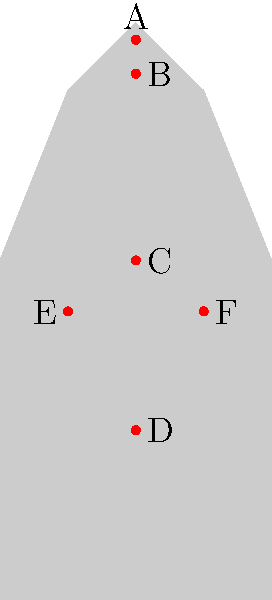Identify the vulnerable body point that, when struck, can potentially cause the most immediate incapacitation in a self-defense situation. Refer to the labeled points (A-F) on the human silhouette diagram. To identify the most vulnerable point for immediate incapacitation, let's analyze each labeled point:

1. Point A: This represents the eyes. While striking the eyes can be effective, it may not cause immediate incapacitation.

2. Point B: This is the throat area. Strikes to the throat can be very dangerous and potentially lethal, but may not always result in immediate incapacitation.

3. Point C: This appears to be the solar plexus. A strong strike here can knock the wind out of an opponent, but it's not the most effective for immediate incapacitation.

4. Point D: This is likely the groin area. While extremely painful, it may not always cause immediate incapacitation, especially if the attacker is under the influence of drugs or adrenaline.

5. Point E: This seems to be the liver area. A strike here can cause significant pain and potentially incapacitate, but it's not the most reliable point for immediate effect.

6. Point F: This represents the carotid sinus, located on the side of the neck. A properly executed strike to this area can disrupt blood flow to the brain, potentially causing immediate unconsciousness.

Based on this analysis, Point F (the carotid sinus) is the most likely to cause immediate incapacitation when struck correctly. It affects the brain's blood supply directly, which can lead to a rapid loss of consciousness.
Answer: F (carotid sinus) 